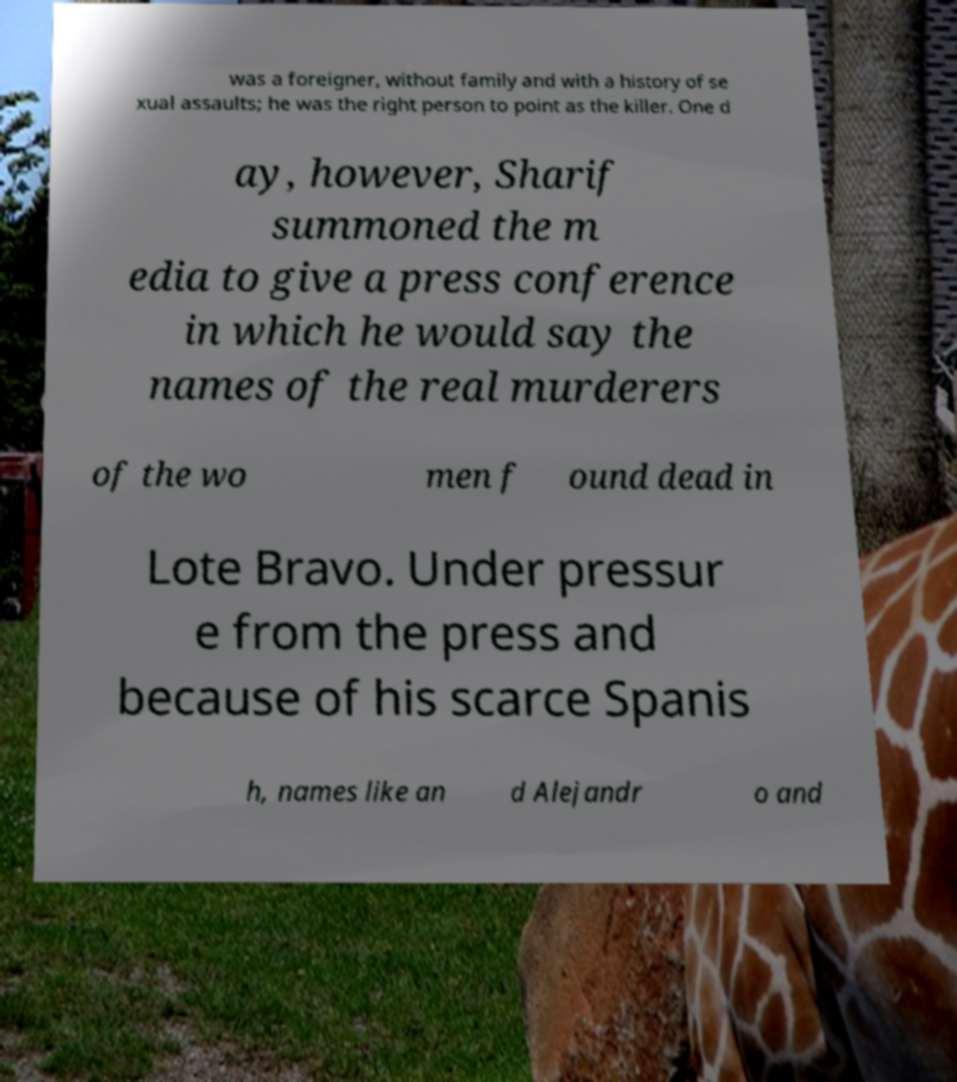Could you extract and type out the text from this image? was a foreigner, without family and with a history of se xual assaults; he was the right person to point as the killer. One d ay, however, Sharif summoned the m edia to give a press conference in which he would say the names of the real murderers of the wo men f ound dead in Lote Bravo. Under pressur e from the press and because of his scarce Spanis h, names like an d Alejandr o and 